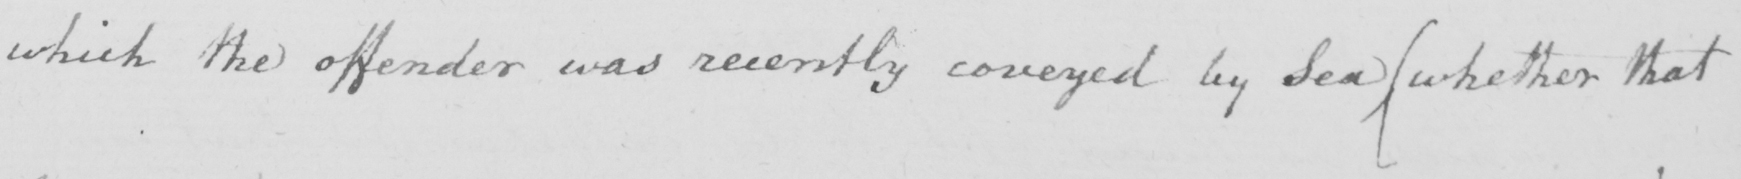Please transcribe the handwritten text in this image. which the offender was recently coveyed by Sea  ( whether that 